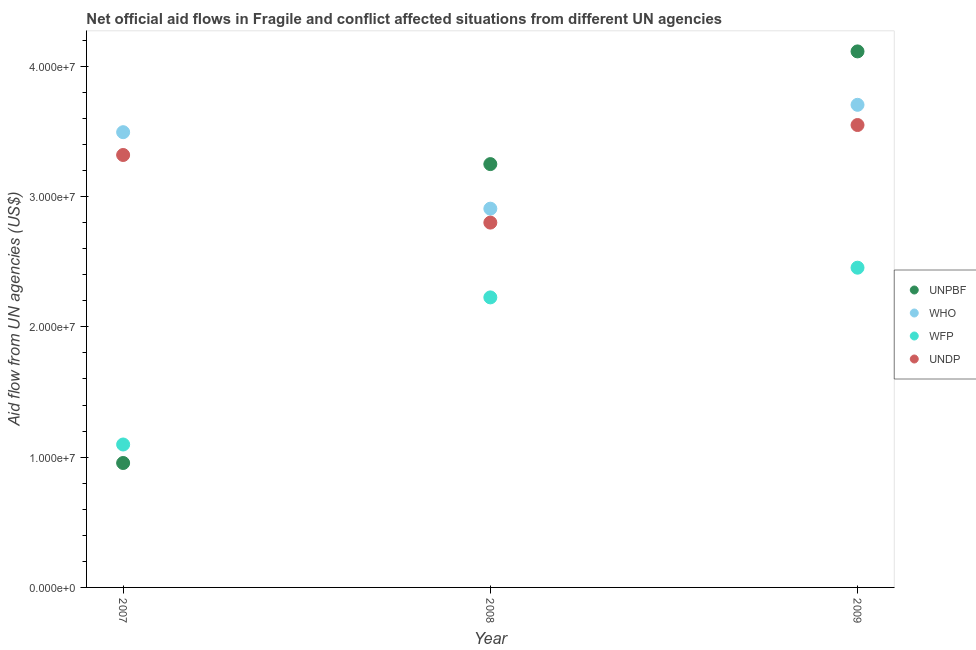What is the amount of aid given by unpbf in 2007?
Offer a terse response. 9.55e+06. Across all years, what is the maximum amount of aid given by unpbf?
Provide a succinct answer. 4.11e+07. Across all years, what is the minimum amount of aid given by wfp?
Give a very brief answer. 1.10e+07. In which year was the amount of aid given by undp minimum?
Give a very brief answer. 2008. What is the total amount of aid given by undp in the graph?
Provide a short and direct response. 9.67e+07. What is the difference between the amount of aid given by wfp in 2008 and that in 2009?
Ensure brevity in your answer.  -2.28e+06. What is the difference between the amount of aid given by unpbf in 2007 and the amount of aid given by undp in 2008?
Your response must be concise. -1.84e+07. What is the average amount of aid given by undp per year?
Provide a succinct answer. 3.22e+07. In the year 2008, what is the difference between the amount of aid given by who and amount of aid given by wfp?
Offer a terse response. 6.81e+06. In how many years, is the amount of aid given by undp greater than 38000000 US$?
Provide a short and direct response. 0. What is the ratio of the amount of aid given by who in 2008 to that in 2009?
Offer a very short reply. 0.78. Is the amount of aid given by wfp in 2007 less than that in 2008?
Offer a very short reply. Yes. Is the difference between the amount of aid given by wfp in 2007 and 2009 greater than the difference between the amount of aid given by who in 2007 and 2009?
Provide a short and direct response. No. What is the difference between the highest and the second highest amount of aid given by wfp?
Keep it short and to the point. 2.28e+06. What is the difference between the highest and the lowest amount of aid given by undp?
Make the answer very short. 7.49e+06. Is it the case that in every year, the sum of the amount of aid given by wfp and amount of aid given by unpbf is greater than the sum of amount of aid given by who and amount of aid given by undp?
Your answer should be very brief. No. Is it the case that in every year, the sum of the amount of aid given by unpbf and amount of aid given by who is greater than the amount of aid given by wfp?
Keep it short and to the point. Yes. Does the amount of aid given by who monotonically increase over the years?
Your answer should be very brief. No. Is the amount of aid given by undp strictly greater than the amount of aid given by who over the years?
Ensure brevity in your answer.  No. How many dotlines are there?
Your answer should be very brief. 4. How many years are there in the graph?
Your answer should be compact. 3. What is the difference between two consecutive major ticks on the Y-axis?
Give a very brief answer. 1.00e+07. Does the graph contain any zero values?
Offer a very short reply. No. How many legend labels are there?
Your answer should be very brief. 4. What is the title of the graph?
Provide a short and direct response. Net official aid flows in Fragile and conflict affected situations from different UN agencies. Does "Corruption" appear as one of the legend labels in the graph?
Your answer should be very brief. No. What is the label or title of the X-axis?
Give a very brief answer. Year. What is the label or title of the Y-axis?
Provide a succinct answer. Aid flow from UN agencies (US$). What is the Aid flow from UN agencies (US$) of UNPBF in 2007?
Your answer should be very brief. 9.55e+06. What is the Aid flow from UN agencies (US$) of WHO in 2007?
Provide a succinct answer. 3.49e+07. What is the Aid flow from UN agencies (US$) in WFP in 2007?
Provide a short and direct response. 1.10e+07. What is the Aid flow from UN agencies (US$) of UNDP in 2007?
Keep it short and to the point. 3.32e+07. What is the Aid flow from UN agencies (US$) in UNPBF in 2008?
Make the answer very short. 3.25e+07. What is the Aid flow from UN agencies (US$) in WHO in 2008?
Provide a short and direct response. 2.91e+07. What is the Aid flow from UN agencies (US$) of WFP in 2008?
Your answer should be very brief. 2.23e+07. What is the Aid flow from UN agencies (US$) in UNDP in 2008?
Offer a terse response. 2.80e+07. What is the Aid flow from UN agencies (US$) in UNPBF in 2009?
Make the answer very short. 4.11e+07. What is the Aid flow from UN agencies (US$) of WHO in 2009?
Your answer should be compact. 3.70e+07. What is the Aid flow from UN agencies (US$) of WFP in 2009?
Your answer should be very brief. 2.45e+07. What is the Aid flow from UN agencies (US$) of UNDP in 2009?
Offer a terse response. 3.55e+07. Across all years, what is the maximum Aid flow from UN agencies (US$) in UNPBF?
Offer a terse response. 4.11e+07. Across all years, what is the maximum Aid flow from UN agencies (US$) of WHO?
Give a very brief answer. 3.70e+07. Across all years, what is the maximum Aid flow from UN agencies (US$) of WFP?
Ensure brevity in your answer.  2.45e+07. Across all years, what is the maximum Aid flow from UN agencies (US$) in UNDP?
Provide a succinct answer. 3.55e+07. Across all years, what is the minimum Aid flow from UN agencies (US$) of UNPBF?
Offer a very short reply. 9.55e+06. Across all years, what is the minimum Aid flow from UN agencies (US$) in WHO?
Keep it short and to the point. 2.91e+07. Across all years, what is the minimum Aid flow from UN agencies (US$) of WFP?
Offer a terse response. 1.10e+07. Across all years, what is the minimum Aid flow from UN agencies (US$) in UNDP?
Your answer should be compact. 2.80e+07. What is the total Aid flow from UN agencies (US$) in UNPBF in the graph?
Make the answer very short. 8.32e+07. What is the total Aid flow from UN agencies (US$) of WHO in the graph?
Make the answer very short. 1.01e+08. What is the total Aid flow from UN agencies (US$) in WFP in the graph?
Your answer should be very brief. 5.78e+07. What is the total Aid flow from UN agencies (US$) in UNDP in the graph?
Ensure brevity in your answer.  9.67e+07. What is the difference between the Aid flow from UN agencies (US$) in UNPBF in 2007 and that in 2008?
Keep it short and to the point. -2.29e+07. What is the difference between the Aid flow from UN agencies (US$) in WHO in 2007 and that in 2008?
Your response must be concise. 5.87e+06. What is the difference between the Aid flow from UN agencies (US$) of WFP in 2007 and that in 2008?
Provide a short and direct response. -1.13e+07. What is the difference between the Aid flow from UN agencies (US$) of UNDP in 2007 and that in 2008?
Your response must be concise. 5.19e+06. What is the difference between the Aid flow from UN agencies (US$) of UNPBF in 2007 and that in 2009?
Give a very brief answer. -3.16e+07. What is the difference between the Aid flow from UN agencies (US$) of WHO in 2007 and that in 2009?
Provide a short and direct response. -2.10e+06. What is the difference between the Aid flow from UN agencies (US$) of WFP in 2007 and that in 2009?
Ensure brevity in your answer.  -1.36e+07. What is the difference between the Aid flow from UN agencies (US$) in UNDP in 2007 and that in 2009?
Make the answer very short. -2.30e+06. What is the difference between the Aid flow from UN agencies (US$) in UNPBF in 2008 and that in 2009?
Your response must be concise. -8.65e+06. What is the difference between the Aid flow from UN agencies (US$) in WHO in 2008 and that in 2009?
Your answer should be very brief. -7.97e+06. What is the difference between the Aid flow from UN agencies (US$) of WFP in 2008 and that in 2009?
Your response must be concise. -2.28e+06. What is the difference between the Aid flow from UN agencies (US$) of UNDP in 2008 and that in 2009?
Offer a very short reply. -7.49e+06. What is the difference between the Aid flow from UN agencies (US$) of UNPBF in 2007 and the Aid flow from UN agencies (US$) of WHO in 2008?
Offer a terse response. -1.95e+07. What is the difference between the Aid flow from UN agencies (US$) of UNPBF in 2007 and the Aid flow from UN agencies (US$) of WFP in 2008?
Keep it short and to the point. -1.27e+07. What is the difference between the Aid flow from UN agencies (US$) of UNPBF in 2007 and the Aid flow from UN agencies (US$) of UNDP in 2008?
Keep it short and to the point. -1.84e+07. What is the difference between the Aid flow from UN agencies (US$) of WHO in 2007 and the Aid flow from UN agencies (US$) of WFP in 2008?
Your answer should be very brief. 1.27e+07. What is the difference between the Aid flow from UN agencies (US$) in WHO in 2007 and the Aid flow from UN agencies (US$) in UNDP in 2008?
Your answer should be very brief. 6.94e+06. What is the difference between the Aid flow from UN agencies (US$) of WFP in 2007 and the Aid flow from UN agencies (US$) of UNDP in 2008?
Offer a very short reply. -1.70e+07. What is the difference between the Aid flow from UN agencies (US$) in UNPBF in 2007 and the Aid flow from UN agencies (US$) in WHO in 2009?
Your answer should be compact. -2.75e+07. What is the difference between the Aid flow from UN agencies (US$) of UNPBF in 2007 and the Aid flow from UN agencies (US$) of WFP in 2009?
Offer a very short reply. -1.50e+07. What is the difference between the Aid flow from UN agencies (US$) in UNPBF in 2007 and the Aid flow from UN agencies (US$) in UNDP in 2009?
Your answer should be very brief. -2.59e+07. What is the difference between the Aid flow from UN agencies (US$) of WHO in 2007 and the Aid flow from UN agencies (US$) of WFP in 2009?
Offer a terse response. 1.04e+07. What is the difference between the Aid flow from UN agencies (US$) in WHO in 2007 and the Aid flow from UN agencies (US$) in UNDP in 2009?
Ensure brevity in your answer.  -5.50e+05. What is the difference between the Aid flow from UN agencies (US$) in WFP in 2007 and the Aid flow from UN agencies (US$) in UNDP in 2009?
Make the answer very short. -2.45e+07. What is the difference between the Aid flow from UN agencies (US$) in UNPBF in 2008 and the Aid flow from UN agencies (US$) in WHO in 2009?
Your answer should be very brief. -4.55e+06. What is the difference between the Aid flow from UN agencies (US$) in UNPBF in 2008 and the Aid flow from UN agencies (US$) in WFP in 2009?
Ensure brevity in your answer.  7.95e+06. What is the difference between the Aid flow from UN agencies (US$) in UNPBF in 2008 and the Aid flow from UN agencies (US$) in UNDP in 2009?
Provide a short and direct response. -3.00e+06. What is the difference between the Aid flow from UN agencies (US$) in WHO in 2008 and the Aid flow from UN agencies (US$) in WFP in 2009?
Your answer should be very brief. 4.53e+06. What is the difference between the Aid flow from UN agencies (US$) of WHO in 2008 and the Aid flow from UN agencies (US$) of UNDP in 2009?
Give a very brief answer. -6.42e+06. What is the difference between the Aid flow from UN agencies (US$) in WFP in 2008 and the Aid flow from UN agencies (US$) in UNDP in 2009?
Offer a terse response. -1.32e+07. What is the average Aid flow from UN agencies (US$) of UNPBF per year?
Make the answer very short. 2.77e+07. What is the average Aid flow from UN agencies (US$) of WHO per year?
Keep it short and to the point. 3.37e+07. What is the average Aid flow from UN agencies (US$) in WFP per year?
Provide a succinct answer. 1.93e+07. What is the average Aid flow from UN agencies (US$) of UNDP per year?
Your response must be concise. 3.22e+07. In the year 2007, what is the difference between the Aid flow from UN agencies (US$) in UNPBF and Aid flow from UN agencies (US$) in WHO?
Your answer should be very brief. -2.54e+07. In the year 2007, what is the difference between the Aid flow from UN agencies (US$) of UNPBF and Aid flow from UN agencies (US$) of WFP?
Your response must be concise. -1.42e+06. In the year 2007, what is the difference between the Aid flow from UN agencies (US$) in UNPBF and Aid flow from UN agencies (US$) in UNDP?
Make the answer very short. -2.36e+07. In the year 2007, what is the difference between the Aid flow from UN agencies (US$) of WHO and Aid flow from UN agencies (US$) of WFP?
Your answer should be compact. 2.40e+07. In the year 2007, what is the difference between the Aid flow from UN agencies (US$) in WHO and Aid flow from UN agencies (US$) in UNDP?
Give a very brief answer. 1.75e+06. In the year 2007, what is the difference between the Aid flow from UN agencies (US$) in WFP and Aid flow from UN agencies (US$) in UNDP?
Offer a terse response. -2.22e+07. In the year 2008, what is the difference between the Aid flow from UN agencies (US$) in UNPBF and Aid flow from UN agencies (US$) in WHO?
Ensure brevity in your answer.  3.42e+06. In the year 2008, what is the difference between the Aid flow from UN agencies (US$) in UNPBF and Aid flow from UN agencies (US$) in WFP?
Ensure brevity in your answer.  1.02e+07. In the year 2008, what is the difference between the Aid flow from UN agencies (US$) in UNPBF and Aid flow from UN agencies (US$) in UNDP?
Give a very brief answer. 4.49e+06. In the year 2008, what is the difference between the Aid flow from UN agencies (US$) in WHO and Aid flow from UN agencies (US$) in WFP?
Ensure brevity in your answer.  6.81e+06. In the year 2008, what is the difference between the Aid flow from UN agencies (US$) of WHO and Aid flow from UN agencies (US$) of UNDP?
Provide a short and direct response. 1.07e+06. In the year 2008, what is the difference between the Aid flow from UN agencies (US$) in WFP and Aid flow from UN agencies (US$) in UNDP?
Your answer should be compact. -5.74e+06. In the year 2009, what is the difference between the Aid flow from UN agencies (US$) of UNPBF and Aid flow from UN agencies (US$) of WHO?
Provide a short and direct response. 4.10e+06. In the year 2009, what is the difference between the Aid flow from UN agencies (US$) of UNPBF and Aid flow from UN agencies (US$) of WFP?
Your answer should be very brief. 1.66e+07. In the year 2009, what is the difference between the Aid flow from UN agencies (US$) of UNPBF and Aid flow from UN agencies (US$) of UNDP?
Your answer should be very brief. 5.65e+06. In the year 2009, what is the difference between the Aid flow from UN agencies (US$) of WHO and Aid flow from UN agencies (US$) of WFP?
Provide a succinct answer. 1.25e+07. In the year 2009, what is the difference between the Aid flow from UN agencies (US$) of WHO and Aid flow from UN agencies (US$) of UNDP?
Your answer should be very brief. 1.55e+06. In the year 2009, what is the difference between the Aid flow from UN agencies (US$) in WFP and Aid flow from UN agencies (US$) in UNDP?
Offer a very short reply. -1.10e+07. What is the ratio of the Aid flow from UN agencies (US$) in UNPBF in 2007 to that in 2008?
Your response must be concise. 0.29. What is the ratio of the Aid flow from UN agencies (US$) in WHO in 2007 to that in 2008?
Your answer should be compact. 1.2. What is the ratio of the Aid flow from UN agencies (US$) of WFP in 2007 to that in 2008?
Provide a short and direct response. 0.49. What is the ratio of the Aid flow from UN agencies (US$) of UNDP in 2007 to that in 2008?
Your response must be concise. 1.19. What is the ratio of the Aid flow from UN agencies (US$) of UNPBF in 2007 to that in 2009?
Offer a very short reply. 0.23. What is the ratio of the Aid flow from UN agencies (US$) in WHO in 2007 to that in 2009?
Provide a short and direct response. 0.94. What is the ratio of the Aid flow from UN agencies (US$) in WFP in 2007 to that in 2009?
Your answer should be compact. 0.45. What is the ratio of the Aid flow from UN agencies (US$) in UNDP in 2007 to that in 2009?
Keep it short and to the point. 0.94. What is the ratio of the Aid flow from UN agencies (US$) of UNPBF in 2008 to that in 2009?
Provide a succinct answer. 0.79. What is the ratio of the Aid flow from UN agencies (US$) of WHO in 2008 to that in 2009?
Offer a terse response. 0.78. What is the ratio of the Aid flow from UN agencies (US$) of WFP in 2008 to that in 2009?
Make the answer very short. 0.91. What is the ratio of the Aid flow from UN agencies (US$) of UNDP in 2008 to that in 2009?
Give a very brief answer. 0.79. What is the difference between the highest and the second highest Aid flow from UN agencies (US$) of UNPBF?
Keep it short and to the point. 8.65e+06. What is the difference between the highest and the second highest Aid flow from UN agencies (US$) of WHO?
Your response must be concise. 2.10e+06. What is the difference between the highest and the second highest Aid flow from UN agencies (US$) in WFP?
Keep it short and to the point. 2.28e+06. What is the difference between the highest and the second highest Aid flow from UN agencies (US$) in UNDP?
Your answer should be compact. 2.30e+06. What is the difference between the highest and the lowest Aid flow from UN agencies (US$) of UNPBF?
Keep it short and to the point. 3.16e+07. What is the difference between the highest and the lowest Aid flow from UN agencies (US$) in WHO?
Your response must be concise. 7.97e+06. What is the difference between the highest and the lowest Aid flow from UN agencies (US$) of WFP?
Your response must be concise. 1.36e+07. What is the difference between the highest and the lowest Aid flow from UN agencies (US$) in UNDP?
Ensure brevity in your answer.  7.49e+06. 